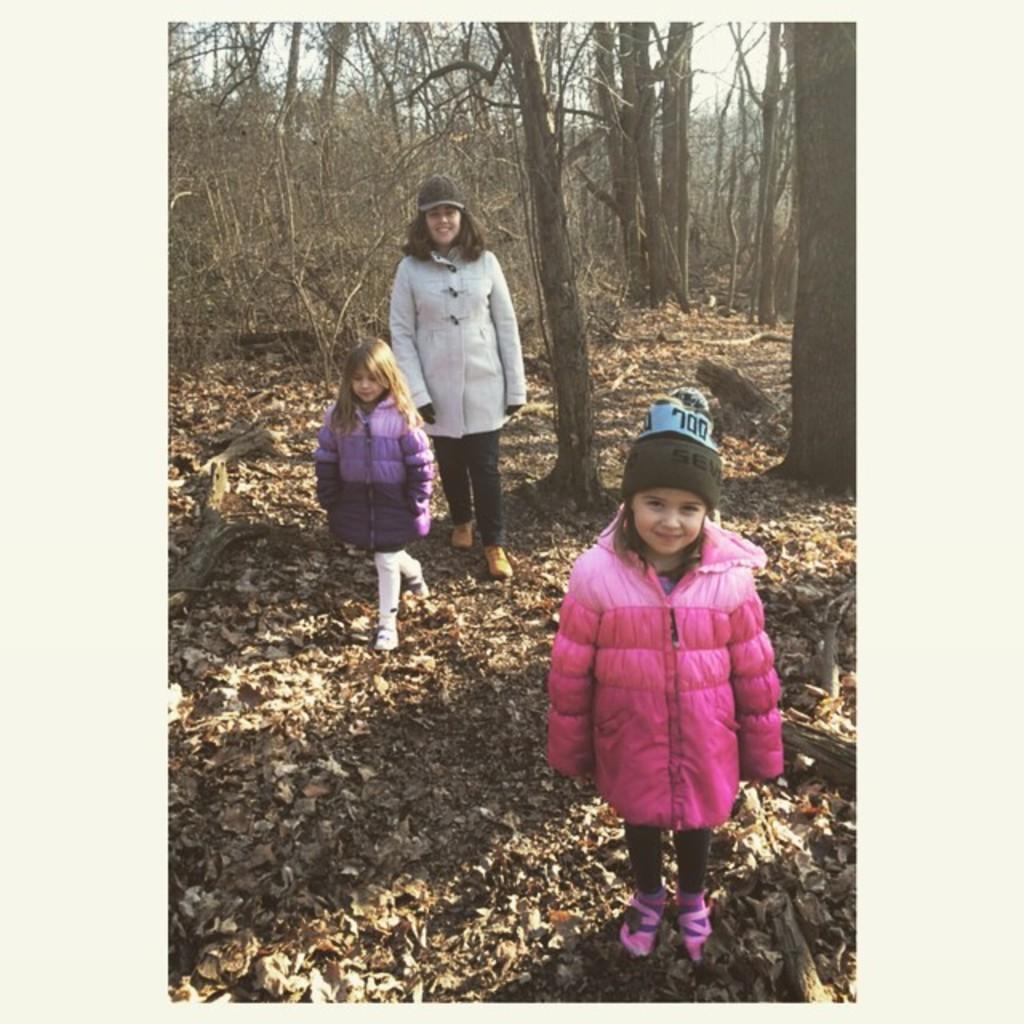Please provide a concise description of this image. In this picture we can observe three members. Two of them were girls and one of them was a woman wearing a cap and smiling. We can observe a girl wearing pink color jacket. We can observe dried leaves and logs on the ground. In the background there are trees and a sky. 